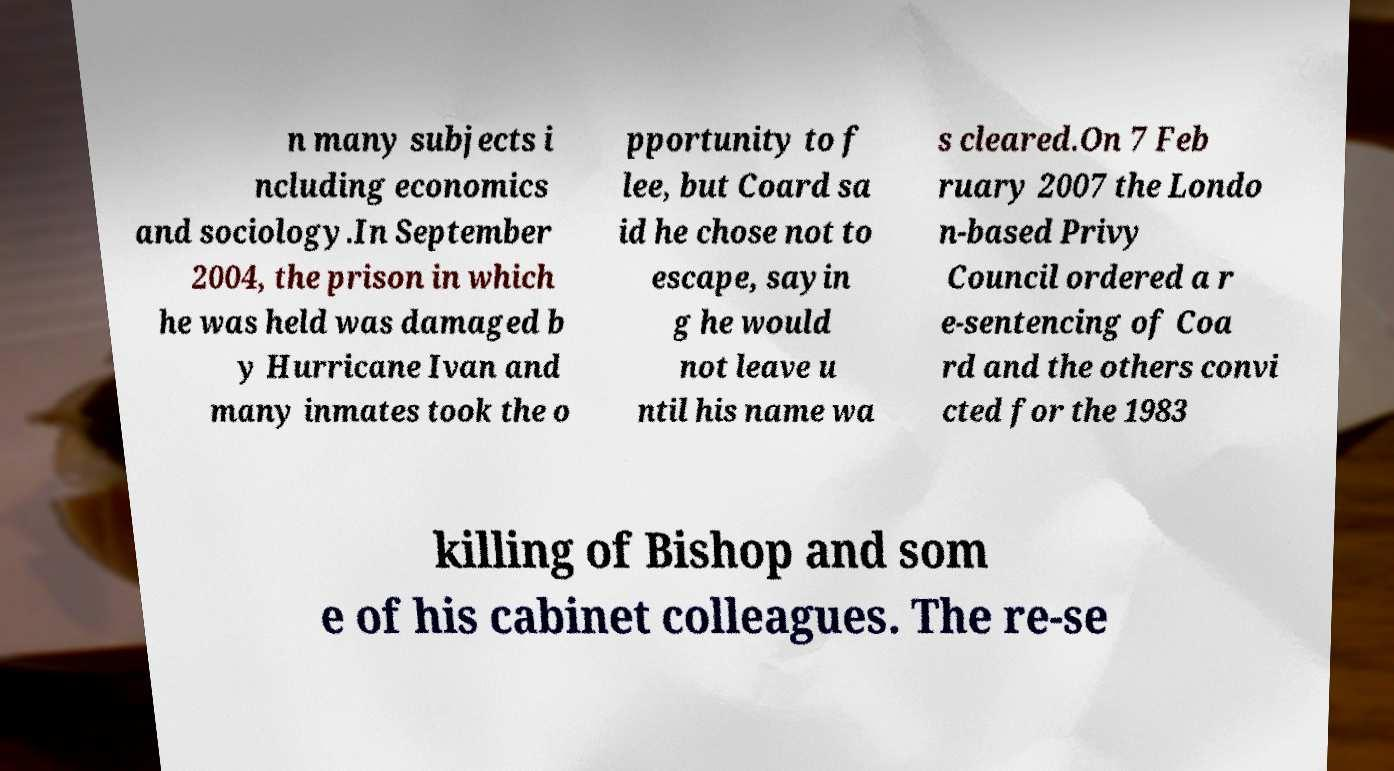Can you read and provide the text displayed in the image?This photo seems to have some interesting text. Can you extract and type it out for me? n many subjects i ncluding economics and sociology.In September 2004, the prison in which he was held was damaged b y Hurricane Ivan and many inmates took the o pportunity to f lee, but Coard sa id he chose not to escape, sayin g he would not leave u ntil his name wa s cleared.On 7 Feb ruary 2007 the Londo n-based Privy Council ordered a r e-sentencing of Coa rd and the others convi cted for the 1983 killing of Bishop and som e of his cabinet colleagues. The re-se 